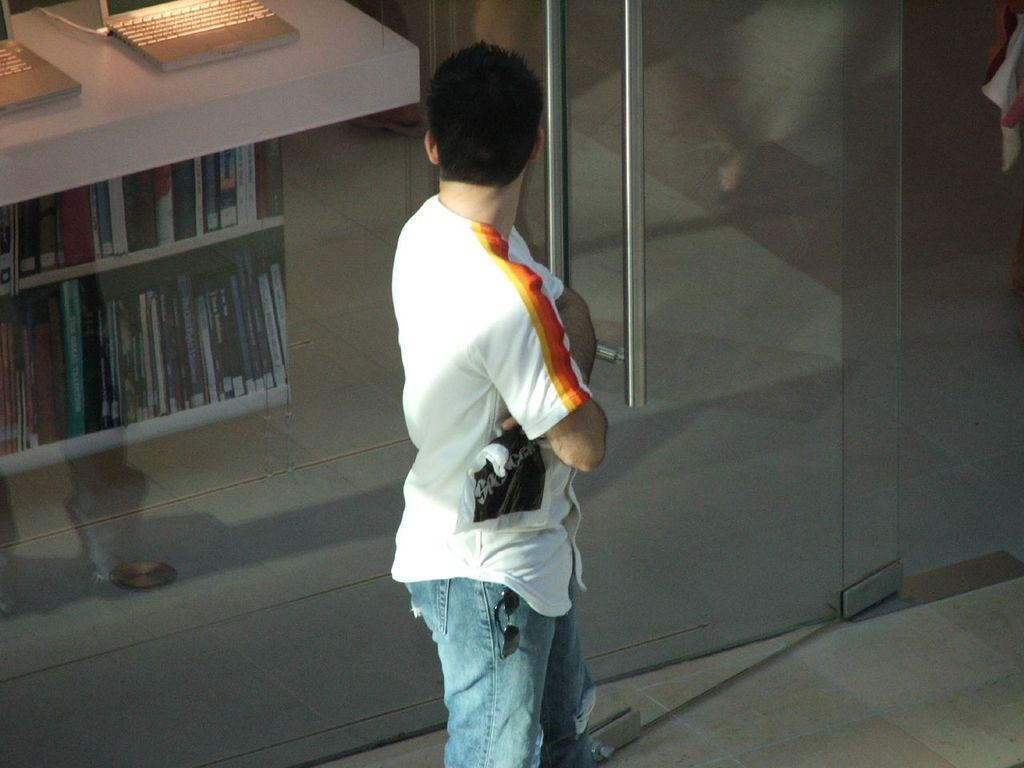Who is the main subject in the image? There is a boy in the center of the image. What can be seen on the left side of the image? There is a bookshelf on the left side of the image. Are there any electronic devices visible in the image? Yes, there are laptops in the top left side of the image. Is there any dust visible on the laptops in the image? The provided facts do not mention any dust on the laptops, so we cannot determine if dust is visible in the image. 